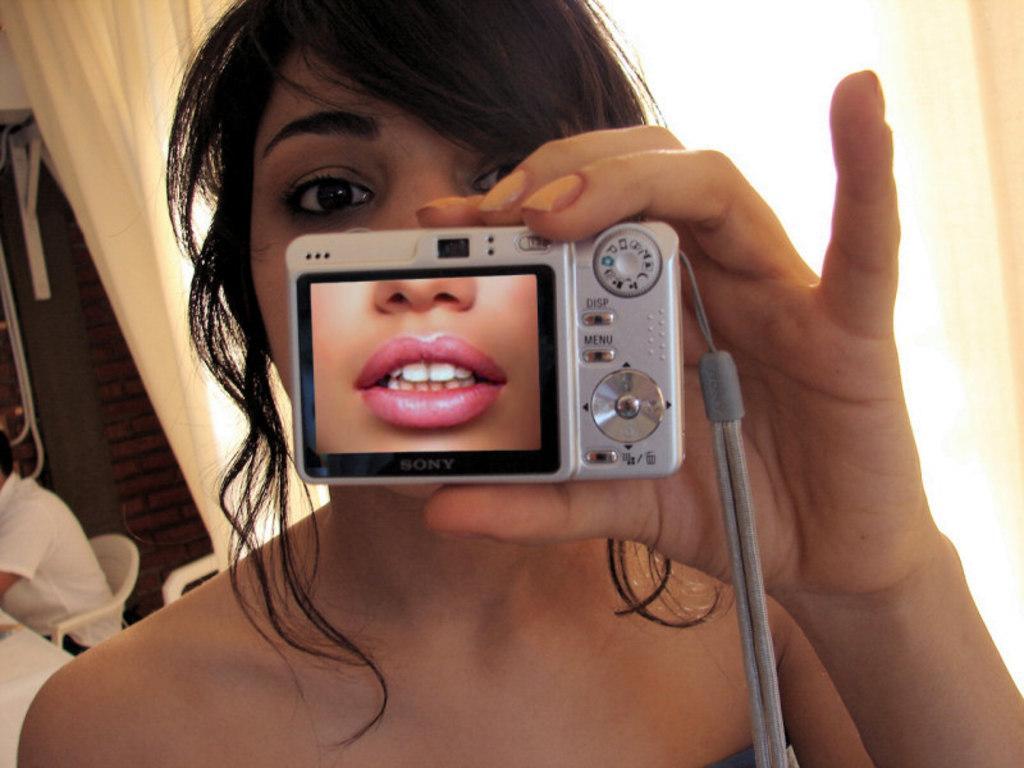Describe this image in one or two sentences. In this image a woman is there who is holding a camera in her hand , who is half visible. In the left bottom a person sitting on the chair half visible in front of the table and a door visible and a curtain of white in color and background is visible. This image is taken inside a room. 